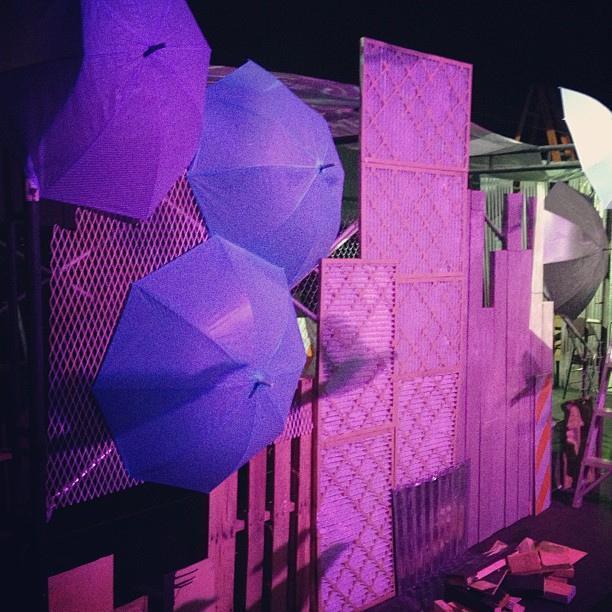How many purple umbrellas are there?
Give a very brief answer. 3. How many umbrellas are in the photo?
Give a very brief answer. 5. 